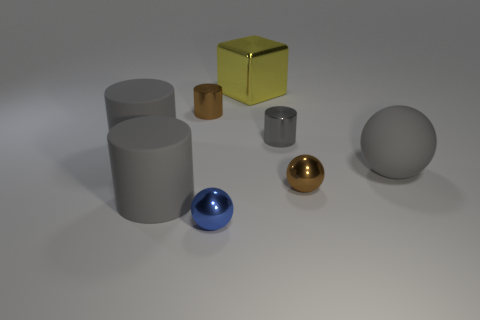What color is the big rubber ball that is in front of the tiny brown shiny cylinder?
Provide a short and direct response. Gray. There is a gray matte cylinder that is behind the gray sphere; does it have the same size as the blue shiny ball?
Offer a very short reply. No. The brown metallic thing that is the same shape as the small gray object is what size?
Keep it short and to the point. Small. Are there fewer big gray rubber cylinders that are to the right of the large shiny block than objects that are to the left of the brown metallic cylinder?
Your answer should be compact. Yes. What number of gray rubber balls are in front of the matte ball?
Provide a succinct answer. 0. Does the tiny metal thing in front of the brown metal sphere have the same shape as the small brown thing that is left of the small gray metal cylinder?
Provide a succinct answer. No. How many other things are there of the same color as the large ball?
Ensure brevity in your answer.  3. What material is the large gray cylinder that is behind the small metal ball that is to the right of the tiny metal sphere on the left side of the large yellow metallic object made of?
Give a very brief answer. Rubber. What is the material of the block on the left side of the cylinder to the right of the blue metallic ball?
Give a very brief answer. Metal. Is the number of large metallic things to the left of the big ball less than the number of small brown metallic cylinders?
Offer a terse response. No. 